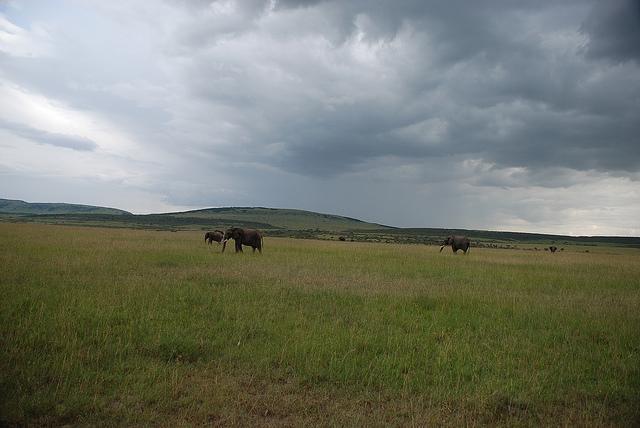How many animal species are shown?
Give a very brief answer. 1. How many trees are in the field?
Give a very brief answer. 0. 